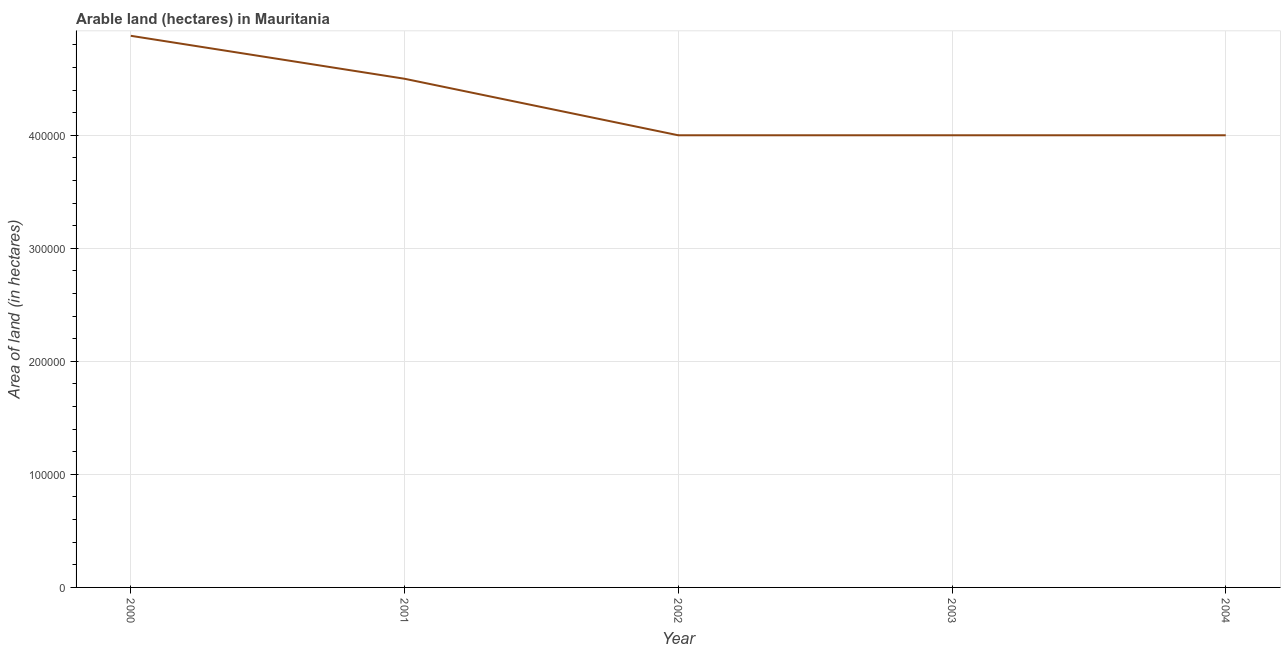What is the area of land in 2004?
Your answer should be compact. 4.00e+05. Across all years, what is the maximum area of land?
Your response must be concise. 4.88e+05. Across all years, what is the minimum area of land?
Keep it short and to the point. 4.00e+05. What is the sum of the area of land?
Keep it short and to the point. 2.14e+06. What is the average area of land per year?
Keep it short and to the point. 4.28e+05. What is the ratio of the area of land in 2001 to that in 2003?
Offer a very short reply. 1.12. Is the area of land in 2000 less than that in 2004?
Your response must be concise. No. What is the difference between the highest and the second highest area of land?
Offer a terse response. 3.80e+04. Is the sum of the area of land in 2001 and 2002 greater than the maximum area of land across all years?
Make the answer very short. Yes. What is the difference between the highest and the lowest area of land?
Ensure brevity in your answer.  8.80e+04. What is the difference between two consecutive major ticks on the Y-axis?
Make the answer very short. 1.00e+05. Are the values on the major ticks of Y-axis written in scientific E-notation?
Offer a terse response. No. Does the graph contain any zero values?
Keep it short and to the point. No. Does the graph contain grids?
Give a very brief answer. Yes. What is the title of the graph?
Give a very brief answer. Arable land (hectares) in Mauritania. What is the label or title of the X-axis?
Your response must be concise. Year. What is the label or title of the Y-axis?
Your response must be concise. Area of land (in hectares). What is the Area of land (in hectares) in 2000?
Offer a very short reply. 4.88e+05. What is the Area of land (in hectares) of 2001?
Your response must be concise. 4.50e+05. What is the Area of land (in hectares) of 2002?
Your answer should be very brief. 4.00e+05. What is the Area of land (in hectares) of 2004?
Your answer should be very brief. 4.00e+05. What is the difference between the Area of land (in hectares) in 2000 and 2001?
Your response must be concise. 3.80e+04. What is the difference between the Area of land (in hectares) in 2000 and 2002?
Your response must be concise. 8.80e+04. What is the difference between the Area of land (in hectares) in 2000 and 2003?
Your answer should be compact. 8.80e+04. What is the difference between the Area of land (in hectares) in 2000 and 2004?
Give a very brief answer. 8.80e+04. What is the difference between the Area of land (in hectares) in 2001 and 2003?
Offer a terse response. 5.00e+04. What is the ratio of the Area of land (in hectares) in 2000 to that in 2001?
Ensure brevity in your answer.  1.08. What is the ratio of the Area of land (in hectares) in 2000 to that in 2002?
Keep it short and to the point. 1.22. What is the ratio of the Area of land (in hectares) in 2000 to that in 2003?
Provide a short and direct response. 1.22. What is the ratio of the Area of land (in hectares) in 2000 to that in 2004?
Ensure brevity in your answer.  1.22. What is the ratio of the Area of land (in hectares) in 2001 to that in 2002?
Provide a succinct answer. 1.12. What is the ratio of the Area of land (in hectares) in 2001 to that in 2003?
Make the answer very short. 1.12. What is the ratio of the Area of land (in hectares) in 2001 to that in 2004?
Your answer should be compact. 1.12. What is the ratio of the Area of land (in hectares) in 2002 to that in 2003?
Provide a short and direct response. 1. What is the ratio of the Area of land (in hectares) in 2002 to that in 2004?
Provide a short and direct response. 1. What is the ratio of the Area of land (in hectares) in 2003 to that in 2004?
Provide a short and direct response. 1. 